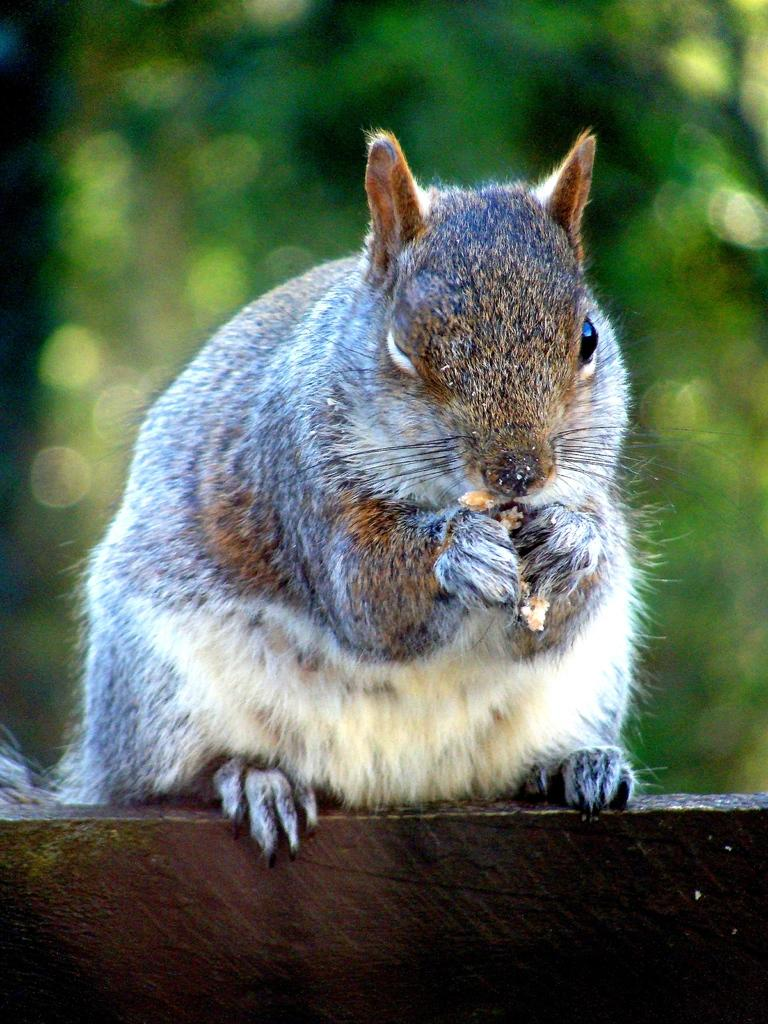What animal is present in the image? There is a squirrel in the image. What is the squirrel doing in the image? The squirrel is holding food in the image. What color is predominant in the background of the image? The background of the image is green. How many chickens are flying in space in the image? There are no chickens or space present in the image; it features a squirrel holding food with a green background. 